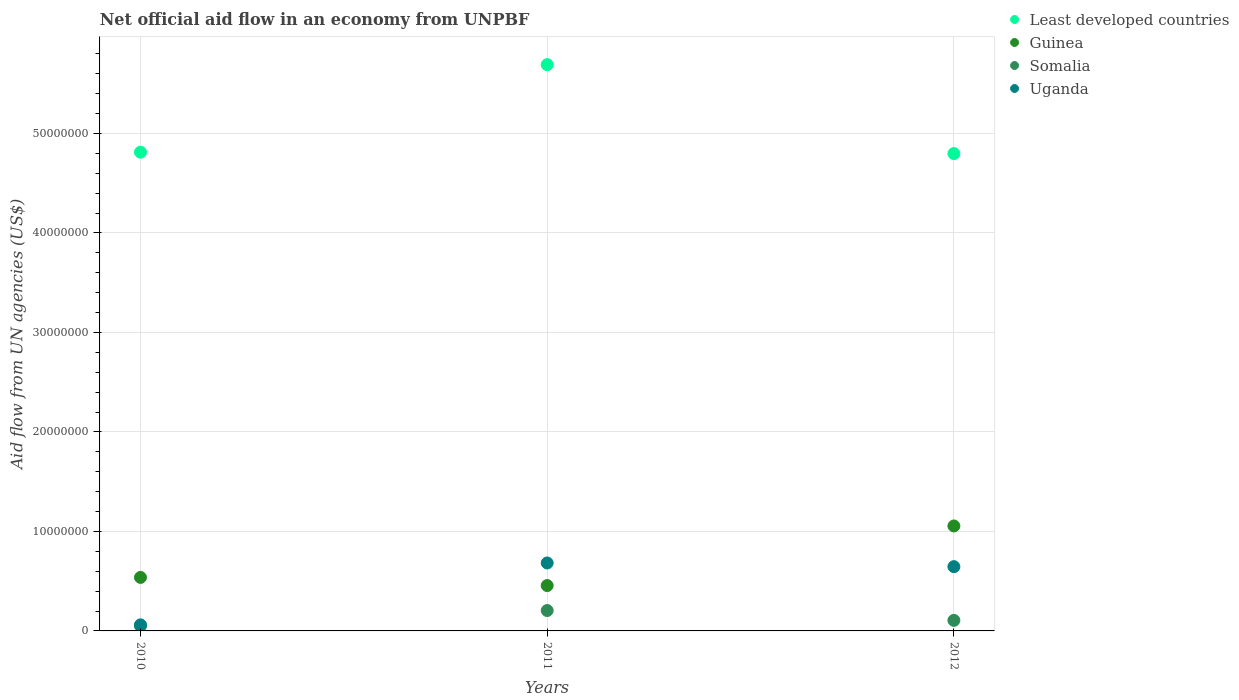What is the net official aid flow in Somalia in 2010?
Your answer should be very brief. 5.10e+05. Across all years, what is the maximum net official aid flow in Uganda?
Provide a short and direct response. 6.83e+06. Across all years, what is the minimum net official aid flow in Guinea?
Your answer should be compact. 4.56e+06. In which year was the net official aid flow in Guinea maximum?
Your response must be concise. 2012. In which year was the net official aid flow in Uganda minimum?
Provide a succinct answer. 2010. What is the total net official aid flow in Least developed countries in the graph?
Your answer should be compact. 1.53e+08. What is the difference between the net official aid flow in Uganda in 2011 and that in 2012?
Ensure brevity in your answer.  3.70e+05. What is the difference between the net official aid flow in Somalia in 2012 and the net official aid flow in Least developed countries in 2010?
Offer a very short reply. -4.71e+07. What is the average net official aid flow in Somalia per year?
Ensure brevity in your answer.  1.21e+06. In the year 2012, what is the difference between the net official aid flow in Uganda and net official aid flow in Guinea?
Provide a succinct answer. -4.09e+06. What is the ratio of the net official aid flow in Guinea in 2011 to that in 2012?
Offer a very short reply. 0.43. What is the difference between the highest and the lowest net official aid flow in Uganda?
Your response must be concise. 6.22e+06. In how many years, is the net official aid flow in Guinea greater than the average net official aid flow in Guinea taken over all years?
Keep it short and to the point. 1. Is it the case that in every year, the sum of the net official aid flow in Uganda and net official aid flow in Somalia  is greater than the sum of net official aid flow in Least developed countries and net official aid flow in Guinea?
Make the answer very short. No. Is it the case that in every year, the sum of the net official aid flow in Somalia and net official aid flow in Least developed countries  is greater than the net official aid flow in Guinea?
Keep it short and to the point. Yes. Is the net official aid flow in Somalia strictly greater than the net official aid flow in Guinea over the years?
Your answer should be very brief. No. How many dotlines are there?
Provide a succinct answer. 4. Are the values on the major ticks of Y-axis written in scientific E-notation?
Your answer should be compact. No. Does the graph contain any zero values?
Ensure brevity in your answer.  No. Does the graph contain grids?
Your answer should be very brief. Yes. How many legend labels are there?
Offer a very short reply. 4. What is the title of the graph?
Offer a very short reply. Net official aid flow in an economy from UNPBF. Does "Spain" appear as one of the legend labels in the graph?
Your response must be concise. No. What is the label or title of the X-axis?
Offer a very short reply. Years. What is the label or title of the Y-axis?
Offer a terse response. Aid flow from UN agencies (US$). What is the Aid flow from UN agencies (US$) in Least developed countries in 2010?
Provide a short and direct response. 4.81e+07. What is the Aid flow from UN agencies (US$) of Guinea in 2010?
Make the answer very short. 5.38e+06. What is the Aid flow from UN agencies (US$) in Somalia in 2010?
Give a very brief answer. 5.10e+05. What is the Aid flow from UN agencies (US$) of Least developed countries in 2011?
Give a very brief answer. 5.69e+07. What is the Aid flow from UN agencies (US$) in Guinea in 2011?
Offer a very short reply. 4.56e+06. What is the Aid flow from UN agencies (US$) of Somalia in 2011?
Your answer should be very brief. 2.05e+06. What is the Aid flow from UN agencies (US$) in Uganda in 2011?
Keep it short and to the point. 6.83e+06. What is the Aid flow from UN agencies (US$) in Least developed countries in 2012?
Ensure brevity in your answer.  4.80e+07. What is the Aid flow from UN agencies (US$) in Guinea in 2012?
Ensure brevity in your answer.  1.06e+07. What is the Aid flow from UN agencies (US$) in Somalia in 2012?
Provide a short and direct response. 1.06e+06. What is the Aid flow from UN agencies (US$) of Uganda in 2012?
Offer a very short reply. 6.46e+06. Across all years, what is the maximum Aid flow from UN agencies (US$) in Least developed countries?
Provide a succinct answer. 5.69e+07. Across all years, what is the maximum Aid flow from UN agencies (US$) in Guinea?
Give a very brief answer. 1.06e+07. Across all years, what is the maximum Aid flow from UN agencies (US$) of Somalia?
Provide a succinct answer. 2.05e+06. Across all years, what is the maximum Aid flow from UN agencies (US$) of Uganda?
Your answer should be compact. 6.83e+06. Across all years, what is the minimum Aid flow from UN agencies (US$) of Least developed countries?
Offer a terse response. 4.80e+07. Across all years, what is the minimum Aid flow from UN agencies (US$) of Guinea?
Provide a succinct answer. 4.56e+06. Across all years, what is the minimum Aid flow from UN agencies (US$) of Somalia?
Your answer should be very brief. 5.10e+05. Across all years, what is the minimum Aid flow from UN agencies (US$) in Uganda?
Keep it short and to the point. 6.10e+05. What is the total Aid flow from UN agencies (US$) in Least developed countries in the graph?
Your answer should be compact. 1.53e+08. What is the total Aid flow from UN agencies (US$) in Guinea in the graph?
Provide a succinct answer. 2.05e+07. What is the total Aid flow from UN agencies (US$) in Somalia in the graph?
Your answer should be very brief. 3.62e+06. What is the total Aid flow from UN agencies (US$) of Uganda in the graph?
Make the answer very short. 1.39e+07. What is the difference between the Aid flow from UN agencies (US$) in Least developed countries in 2010 and that in 2011?
Your answer should be compact. -8.80e+06. What is the difference between the Aid flow from UN agencies (US$) in Guinea in 2010 and that in 2011?
Provide a short and direct response. 8.20e+05. What is the difference between the Aid flow from UN agencies (US$) in Somalia in 2010 and that in 2011?
Offer a very short reply. -1.54e+06. What is the difference between the Aid flow from UN agencies (US$) of Uganda in 2010 and that in 2011?
Keep it short and to the point. -6.22e+06. What is the difference between the Aid flow from UN agencies (US$) in Guinea in 2010 and that in 2012?
Provide a succinct answer. -5.17e+06. What is the difference between the Aid flow from UN agencies (US$) in Somalia in 2010 and that in 2012?
Your response must be concise. -5.50e+05. What is the difference between the Aid flow from UN agencies (US$) in Uganda in 2010 and that in 2012?
Your response must be concise. -5.85e+06. What is the difference between the Aid flow from UN agencies (US$) in Least developed countries in 2011 and that in 2012?
Keep it short and to the point. 8.94e+06. What is the difference between the Aid flow from UN agencies (US$) in Guinea in 2011 and that in 2012?
Provide a short and direct response. -5.99e+06. What is the difference between the Aid flow from UN agencies (US$) in Somalia in 2011 and that in 2012?
Give a very brief answer. 9.90e+05. What is the difference between the Aid flow from UN agencies (US$) in Uganda in 2011 and that in 2012?
Offer a very short reply. 3.70e+05. What is the difference between the Aid flow from UN agencies (US$) of Least developed countries in 2010 and the Aid flow from UN agencies (US$) of Guinea in 2011?
Provide a succinct answer. 4.36e+07. What is the difference between the Aid flow from UN agencies (US$) of Least developed countries in 2010 and the Aid flow from UN agencies (US$) of Somalia in 2011?
Offer a terse response. 4.61e+07. What is the difference between the Aid flow from UN agencies (US$) of Least developed countries in 2010 and the Aid flow from UN agencies (US$) of Uganda in 2011?
Offer a terse response. 4.13e+07. What is the difference between the Aid flow from UN agencies (US$) of Guinea in 2010 and the Aid flow from UN agencies (US$) of Somalia in 2011?
Offer a very short reply. 3.33e+06. What is the difference between the Aid flow from UN agencies (US$) of Guinea in 2010 and the Aid flow from UN agencies (US$) of Uganda in 2011?
Your answer should be compact. -1.45e+06. What is the difference between the Aid flow from UN agencies (US$) of Somalia in 2010 and the Aid flow from UN agencies (US$) of Uganda in 2011?
Your answer should be compact. -6.32e+06. What is the difference between the Aid flow from UN agencies (US$) of Least developed countries in 2010 and the Aid flow from UN agencies (US$) of Guinea in 2012?
Your response must be concise. 3.76e+07. What is the difference between the Aid flow from UN agencies (US$) of Least developed countries in 2010 and the Aid flow from UN agencies (US$) of Somalia in 2012?
Provide a short and direct response. 4.71e+07. What is the difference between the Aid flow from UN agencies (US$) in Least developed countries in 2010 and the Aid flow from UN agencies (US$) in Uganda in 2012?
Offer a very short reply. 4.17e+07. What is the difference between the Aid flow from UN agencies (US$) of Guinea in 2010 and the Aid flow from UN agencies (US$) of Somalia in 2012?
Offer a very short reply. 4.32e+06. What is the difference between the Aid flow from UN agencies (US$) in Guinea in 2010 and the Aid flow from UN agencies (US$) in Uganda in 2012?
Your answer should be compact. -1.08e+06. What is the difference between the Aid flow from UN agencies (US$) in Somalia in 2010 and the Aid flow from UN agencies (US$) in Uganda in 2012?
Make the answer very short. -5.95e+06. What is the difference between the Aid flow from UN agencies (US$) in Least developed countries in 2011 and the Aid flow from UN agencies (US$) in Guinea in 2012?
Keep it short and to the point. 4.64e+07. What is the difference between the Aid flow from UN agencies (US$) of Least developed countries in 2011 and the Aid flow from UN agencies (US$) of Somalia in 2012?
Make the answer very short. 5.59e+07. What is the difference between the Aid flow from UN agencies (US$) in Least developed countries in 2011 and the Aid flow from UN agencies (US$) in Uganda in 2012?
Keep it short and to the point. 5.05e+07. What is the difference between the Aid flow from UN agencies (US$) in Guinea in 2011 and the Aid flow from UN agencies (US$) in Somalia in 2012?
Offer a terse response. 3.50e+06. What is the difference between the Aid flow from UN agencies (US$) of Guinea in 2011 and the Aid flow from UN agencies (US$) of Uganda in 2012?
Provide a short and direct response. -1.90e+06. What is the difference between the Aid flow from UN agencies (US$) in Somalia in 2011 and the Aid flow from UN agencies (US$) in Uganda in 2012?
Provide a succinct answer. -4.41e+06. What is the average Aid flow from UN agencies (US$) in Least developed countries per year?
Give a very brief answer. 5.10e+07. What is the average Aid flow from UN agencies (US$) of Guinea per year?
Give a very brief answer. 6.83e+06. What is the average Aid flow from UN agencies (US$) in Somalia per year?
Offer a terse response. 1.21e+06. What is the average Aid flow from UN agencies (US$) of Uganda per year?
Make the answer very short. 4.63e+06. In the year 2010, what is the difference between the Aid flow from UN agencies (US$) of Least developed countries and Aid flow from UN agencies (US$) of Guinea?
Your answer should be very brief. 4.27e+07. In the year 2010, what is the difference between the Aid flow from UN agencies (US$) of Least developed countries and Aid flow from UN agencies (US$) of Somalia?
Your answer should be very brief. 4.76e+07. In the year 2010, what is the difference between the Aid flow from UN agencies (US$) of Least developed countries and Aid flow from UN agencies (US$) of Uganda?
Your answer should be very brief. 4.75e+07. In the year 2010, what is the difference between the Aid flow from UN agencies (US$) in Guinea and Aid flow from UN agencies (US$) in Somalia?
Your answer should be very brief. 4.87e+06. In the year 2010, what is the difference between the Aid flow from UN agencies (US$) in Guinea and Aid flow from UN agencies (US$) in Uganda?
Ensure brevity in your answer.  4.77e+06. In the year 2010, what is the difference between the Aid flow from UN agencies (US$) of Somalia and Aid flow from UN agencies (US$) of Uganda?
Offer a terse response. -1.00e+05. In the year 2011, what is the difference between the Aid flow from UN agencies (US$) in Least developed countries and Aid flow from UN agencies (US$) in Guinea?
Your answer should be compact. 5.24e+07. In the year 2011, what is the difference between the Aid flow from UN agencies (US$) in Least developed countries and Aid flow from UN agencies (US$) in Somalia?
Provide a succinct answer. 5.49e+07. In the year 2011, what is the difference between the Aid flow from UN agencies (US$) in Least developed countries and Aid flow from UN agencies (US$) in Uganda?
Your answer should be compact. 5.01e+07. In the year 2011, what is the difference between the Aid flow from UN agencies (US$) in Guinea and Aid flow from UN agencies (US$) in Somalia?
Provide a short and direct response. 2.51e+06. In the year 2011, what is the difference between the Aid flow from UN agencies (US$) in Guinea and Aid flow from UN agencies (US$) in Uganda?
Ensure brevity in your answer.  -2.27e+06. In the year 2011, what is the difference between the Aid flow from UN agencies (US$) of Somalia and Aid flow from UN agencies (US$) of Uganda?
Offer a terse response. -4.78e+06. In the year 2012, what is the difference between the Aid flow from UN agencies (US$) in Least developed countries and Aid flow from UN agencies (US$) in Guinea?
Provide a short and direct response. 3.74e+07. In the year 2012, what is the difference between the Aid flow from UN agencies (US$) in Least developed countries and Aid flow from UN agencies (US$) in Somalia?
Give a very brief answer. 4.69e+07. In the year 2012, what is the difference between the Aid flow from UN agencies (US$) of Least developed countries and Aid flow from UN agencies (US$) of Uganda?
Your answer should be very brief. 4.15e+07. In the year 2012, what is the difference between the Aid flow from UN agencies (US$) of Guinea and Aid flow from UN agencies (US$) of Somalia?
Provide a succinct answer. 9.49e+06. In the year 2012, what is the difference between the Aid flow from UN agencies (US$) of Guinea and Aid flow from UN agencies (US$) of Uganda?
Offer a very short reply. 4.09e+06. In the year 2012, what is the difference between the Aid flow from UN agencies (US$) in Somalia and Aid flow from UN agencies (US$) in Uganda?
Your answer should be compact. -5.40e+06. What is the ratio of the Aid flow from UN agencies (US$) in Least developed countries in 2010 to that in 2011?
Your answer should be compact. 0.85. What is the ratio of the Aid flow from UN agencies (US$) in Guinea in 2010 to that in 2011?
Provide a short and direct response. 1.18. What is the ratio of the Aid flow from UN agencies (US$) in Somalia in 2010 to that in 2011?
Your answer should be compact. 0.25. What is the ratio of the Aid flow from UN agencies (US$) in Uganda in 2010 to that in 2011?
Offer a very short reply. 0.09. What is the ratio of the Aid flow from UN agencies (US$) in Least developed countries in 2010 to that in 2012?
Give a very brief answer. 1. What is the ratio of the Aid flow from UN agencies (US$) of Guinea in 2010 to that in 2012?
Offer a terse response. 0.51. What is the ratio of the Aid flow from UN agencies (US$) of Somalia in 2010 to that in 2012?
Make the answer very short. 0.48. What is the ratio of the Aid flow from UN agencies (US$) in Uganda in 2010 to that in 2012?
Make the answer very short. 0.09. What is the ratio of the Aid flow from UN agencies (US$) of Least developed countries in 2011 to that in 2012?
Ensure brevity in your answer.  1.19. What is the ratio of the Aid flow from UN agencies (US$) in Guinea in 2011 to that in 2012?
Your response must be concise. 0.43. What is the ratio of the Aid flow from UN agencies (US$) of Somalia in 2011 to that in 2012?
Your answer should be compact. 1.93. What is the ratio of the Aid flow from UN agencies (US$) in Uganda in 2011 to that in 2012?
Your answer should be very brief. 1.06. What is the difference between the highest and the second highest Aid flow from UN agencies (US$) in Least developed countries?
Keep it short and to the point. 8.80e+06. What is the difference between the highest and the second highest Aid flow from UN agencies (US$) in Guinea?
Ensure brevity in your answer.  5.17e+06. What is the difference between the highest and the second highest Aid flow from UN agencies (US$) of Somalia?
Your answer should be very brief. 9.90e+05. What is the difference between the highest and the second highest Aid flow from UN agencies (US$) of Uganda?
Your response must be concise. 3.70e+05. What is the difference between the highest and the lowest Aid flow from UN agencies (US$) in Least developed countries?
Provide a succinct answer. 8.94e+06. What is the difference between the highest and the lowest Aid flow from UN agencies (US$) of Guinea?
Provide a short and direct response. 5.99e+06. What is the difference between the highest and the lowest Aid flow from UN agencies (US$) in Somalia?
Provide a succinct answer. 1.54e+06. What is the difference between the highest and the lowest Aid flow from UN agencies (US$) of Uganda?
Your response must be concise. 6.22e+06. 